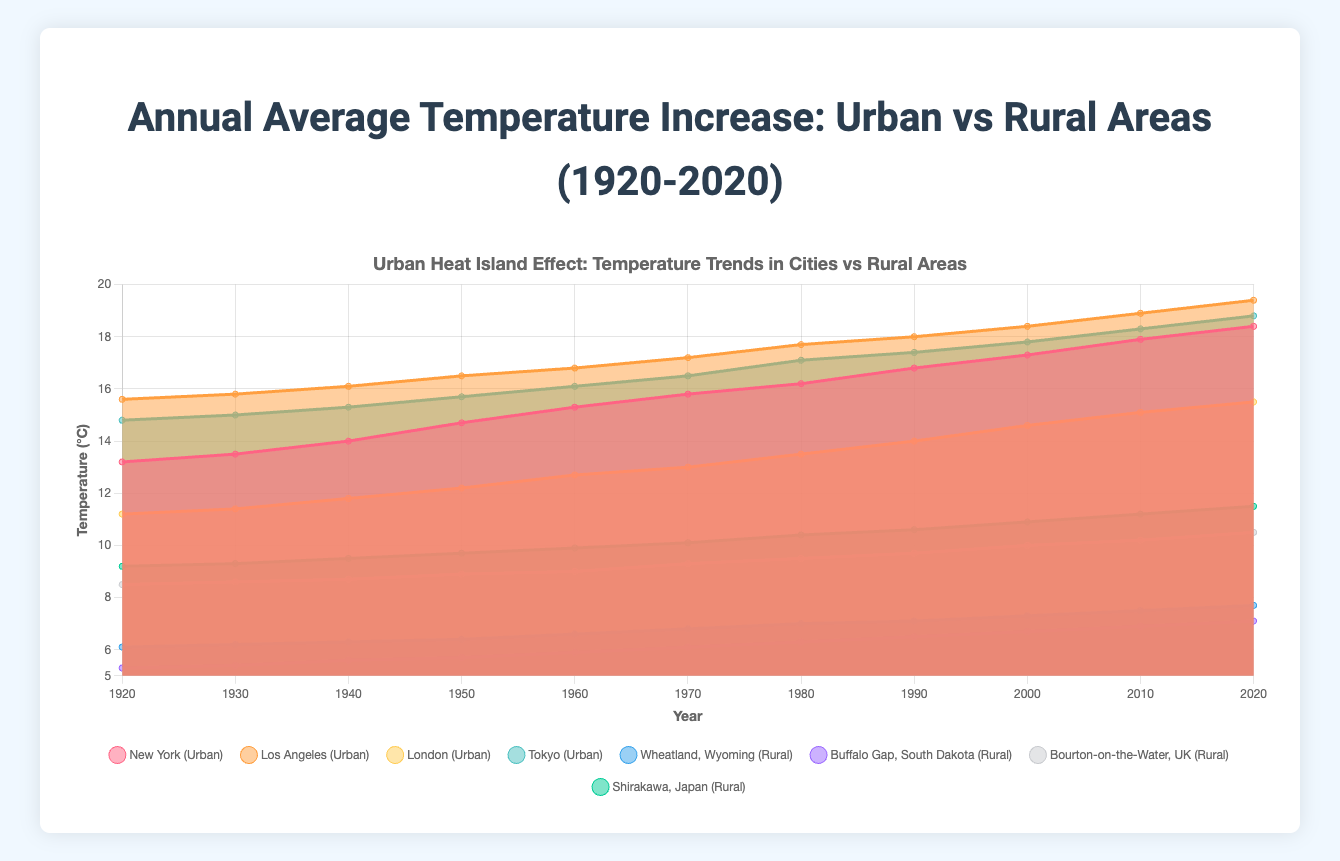What's the title of the chart? The title is displayed at the top of the chart.
Answer: Annual Average Temperature Increase: Urban vs Rural Areas (1920-2020) Which city shows the highest temperature in 2020? Look at the values for each city at the year 2020 on the x-axis and identify the highest temperature.
Answer: Los Angeles How has the temperature in Tokyo changed from 1920 to 2020? Find the temperature in Tokyo for the years 1920 and 2020, then calculate the difference. The temperature in Tokyo increased from 14.8°C in 1920 to 18.8°C in 2020.
Answer: Increased by 4.0°C Compare the temperature increase between New York and Wheatland, Wyoming from 1920 to 2020. Find the temperatures for New York and Wheatland, Wyoming in 1920 and 2020 and calculate the difference for each. New York increased from 13.2°C to 18.4°C (5.2°C increase), and Wheatland, Wyoming increased from 6.1°C to 7.7°C (1.6°C increase).
Answer: New York increased more by 3.6°C What is the average temperature in Bourton-on-the-Water, UK, across all the years? Add up all the temperature values for Bourton-on-the-Water, UK, and divide by the number of years. (8.5 + 8.6 + 8.7 + 8.9 + 9.0 + 9.3 + 9.5 + 9.7 + 10.0 + 10.2 + 10.5) / 11 = 9.18°C
Answer: 9.18°C Which rural area showed the least change in temperature from 1920 to 2020? Find the temperature values for each rural area for the years 1920 and 2020, calculate the change, and identify the smallest change. Buffalo Gap, South Dakota increased from 5.3°C to 7.1°C (1.8°C increase).
Answer: Buffalo Gap, South Dakota What is the overall trend in temperature in urban areas from 1920 to 2020? Observe the changes in temperature for all urban areas across the years. The overall trend is an increase in temperature.
Answer: Increasing trend In which decade did the temperature in Los Angeles first exceed 17°C? Look at the temperature values for Los Angeles and identify the decade when the temperature first exceeded 17°C. The temperature surpassed 17°C in the 1970s.
Answer: 1970s What is the difference between the maximum and minimum temperatures recorded in Shirakawa, Japan, over the 100 years? Find the maximum and minimum temperatures for Shirakawa, Japan, and calculate the difference. The maximum is 11.5°C (2020), and the minimum is 9.2°C (1920), so the difference is 11.5 - 9.2 = 2.3°C.
Answer: 2.3°C 